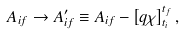<formula> <loc_0><loc_0><loc_500><loc_500>A _ { i f } \rightarrow A _ { i f } ^ { \prime } \equiv A _ { i f } - \left [ q \chi \right ] _ { t _ { i } } ^ { t _ { f } } ,</formula> 